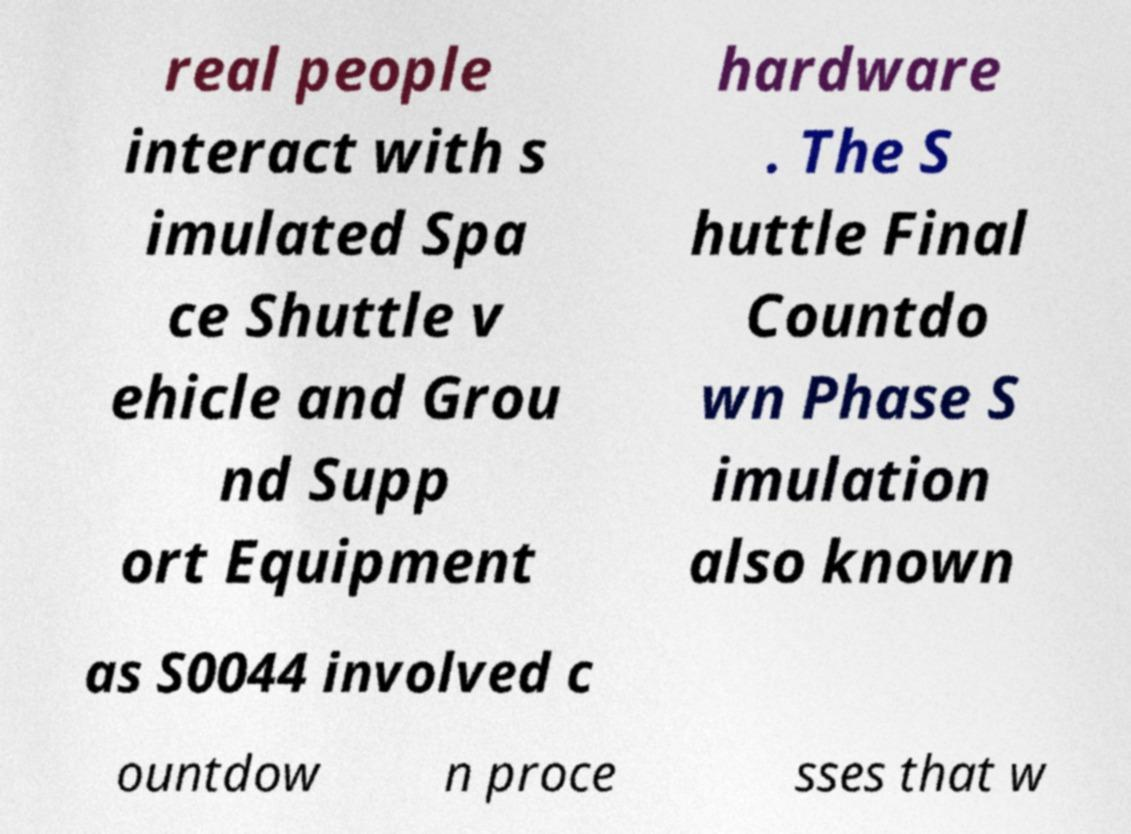Could you assist in decoding the text presented in this image and type it out clearly? real people interact with s imulated Spa ce Shuttle v ehicle and Grou nd Supp ort Equipment hardware . The S huttle Final Countdo wn Phase S imulation also known as S0044 involved c ountdow n proce sses that w 